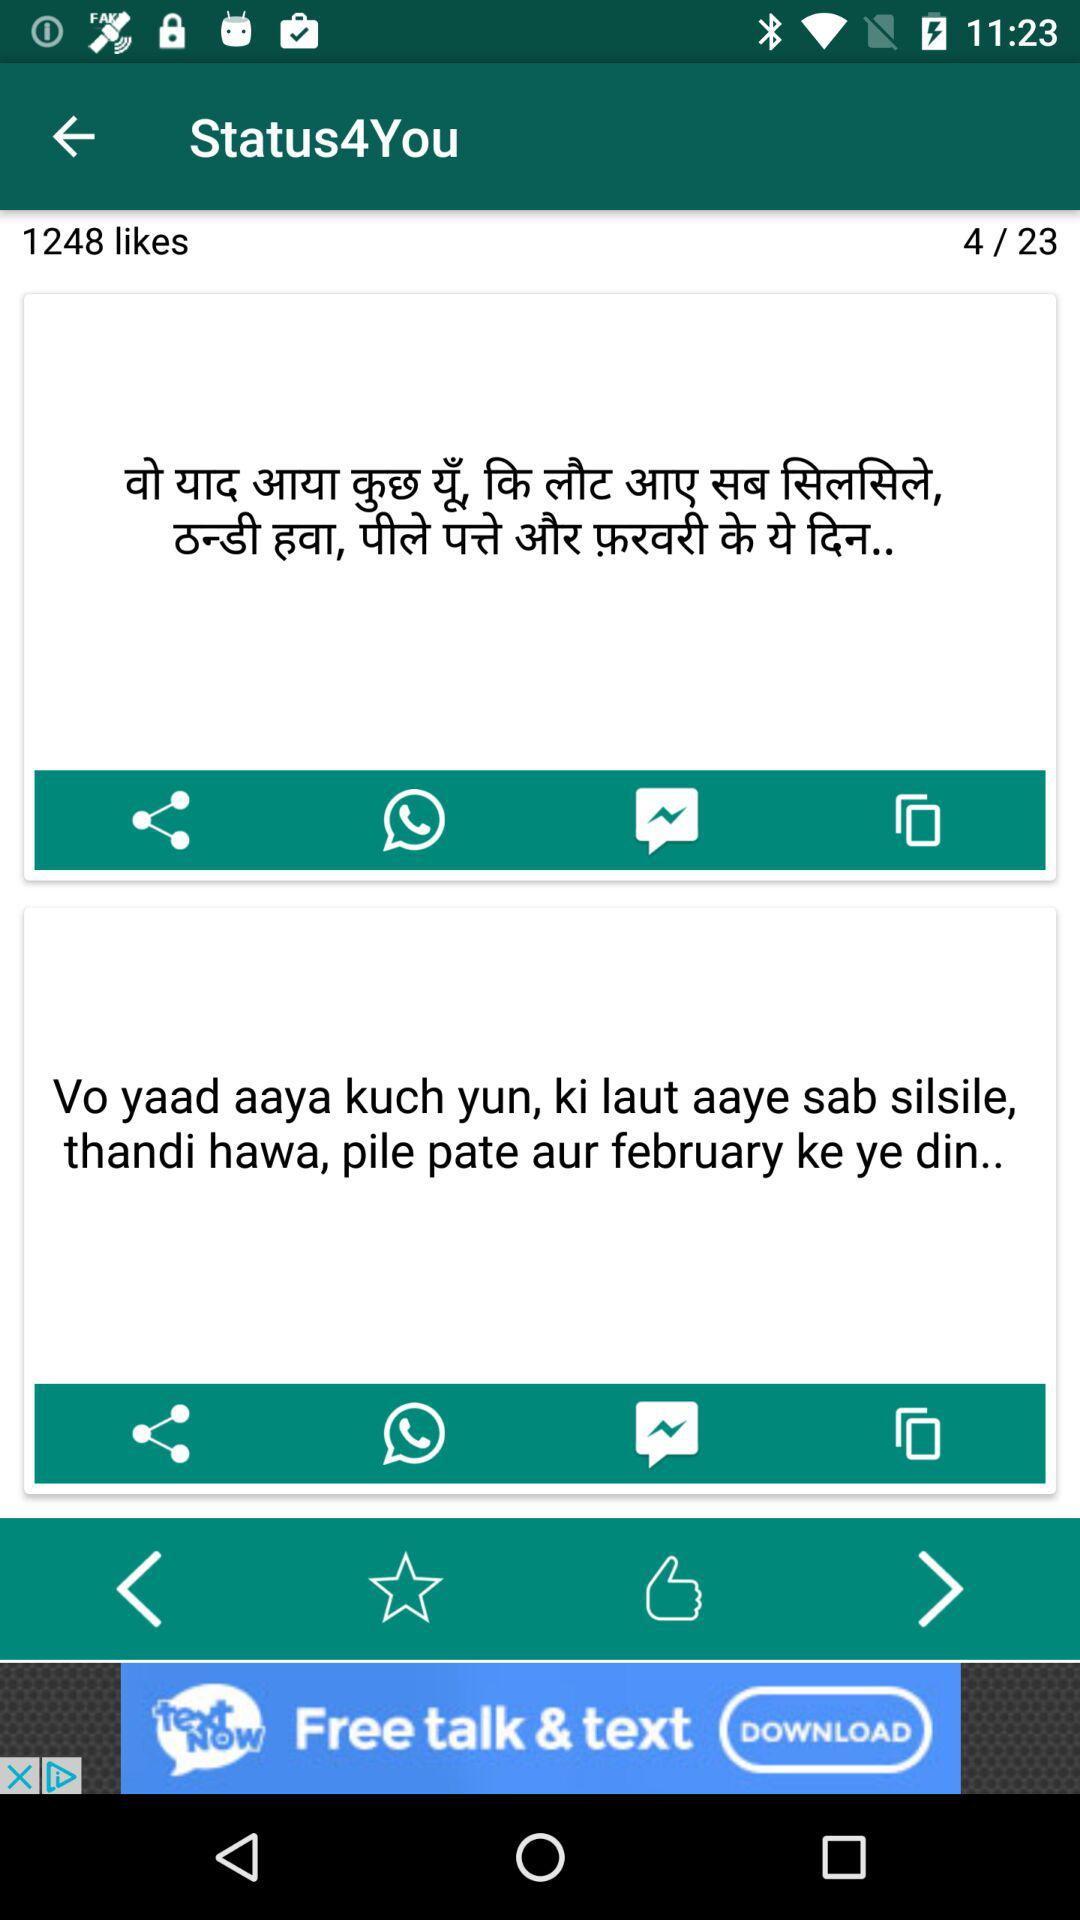How many pages in total are there? There are 23 pages in total. 